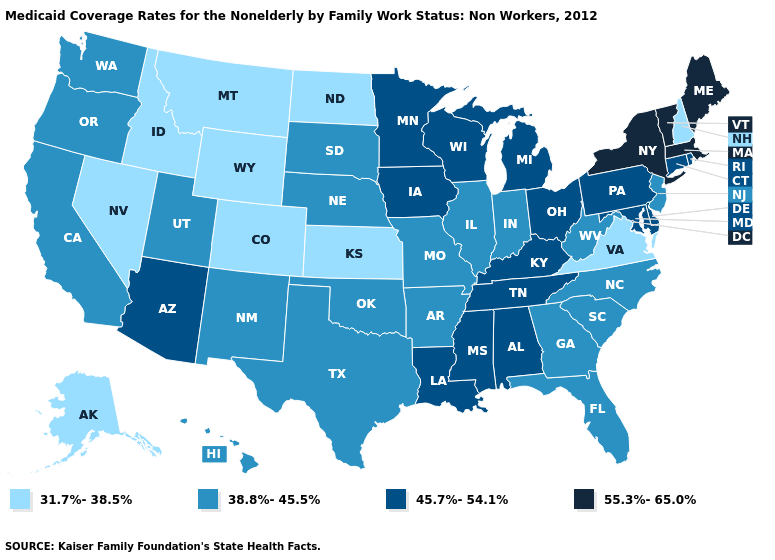What is the lowest value in the USA?
Keep it brief. 31.7%-38.5%. What is the value of Mississippi?
Give a very brief answer. 45.7%-54.1%. What is the value of Maine?
Short answer required. 55.3%-65.0%. What is the value of Oklahoma?
Quick response, please. 38.8%-45.5%. Which states have the highest value in the USA?
Be succinct. Maine, Massachusetts, New York, Vermont. Among the states that border South Carolina , which have the highest value?
Write a very short answer. Georgia, North Carolina. What is the value of North Dakota?
Be succinct. 31.7%-38.5%. Does Alabama have a lower value than North Dakota?
Quick response, please. No. What is the value of Virginia?
Quick response, please. 31.7%-38.5%. Name the states that have a value in the range 55.3%-65.0%?
Answer briefly. Maine, Massachusetts, New York, Vermont. Name the states that have a value in the range 45.7%-54.1%?
Be succinct. Alabama, Arizona, Connecticut, Delaware, Iowa, Kentucky, Louisiana, Maryland, Michigan, Minnesota, Mississippi, Ohio, Pennsylvania, Rhode Island, Tennessee, Wisconsin. Name the states that have a value in the range 55.3%-65.0%?
Give a very brief answer. Maine, Massachusetts, New York, Vermont. Among the states that border Maryland , which have the highest value?
Answer briefly. Delaware, Pennsylvania. Among the states that border Minnesota , does South Dakota have the highest value?
Be succinct. No. Does Ohio have a lower value than Wyoming?
Be succinct. No. 